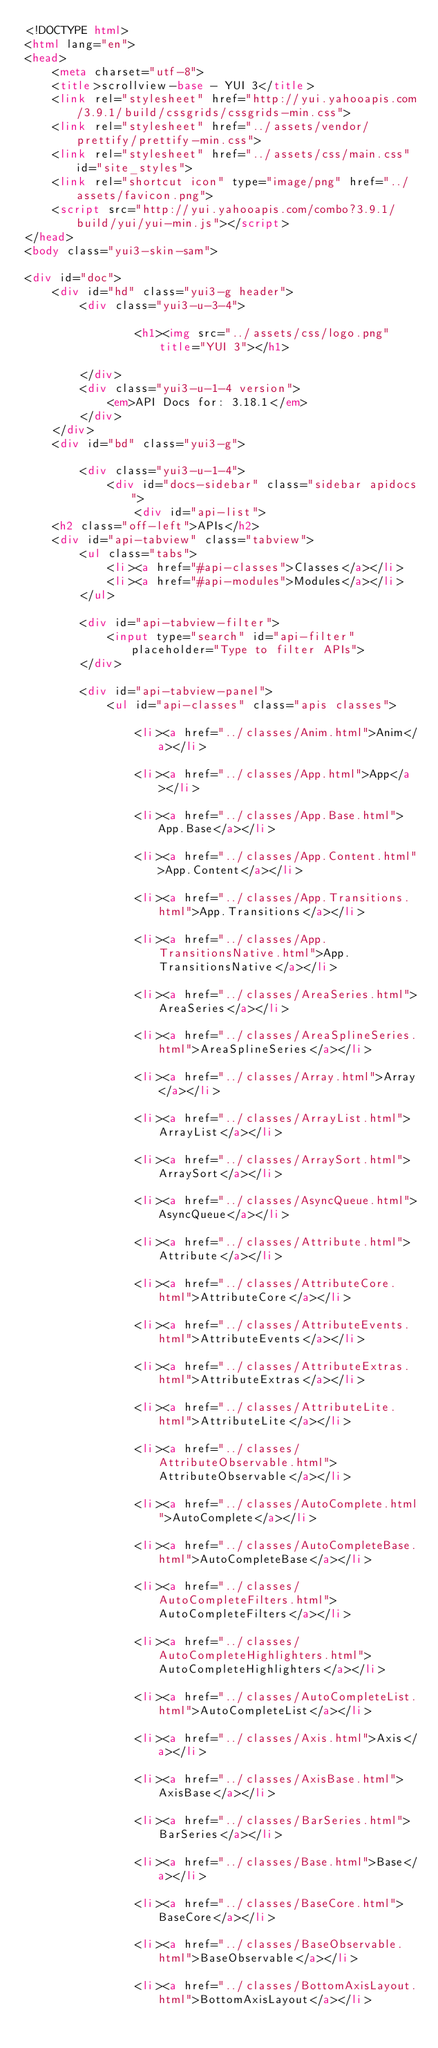Convert code to text. <code><loc_0><loc_0><loc_500><loc_500><_HTML_><!DOCTYPE html>
<html lang="en">
<head>
    <meta charset="utf-8">
    <title>scrollview-base - YUI 3</title>
    <link rel="stylesheet" href="http://yui.yahooapis.com/3.9.1/build/cssgrids/cssgrids-min.css">
    <link rel="stylesheet" href="../assets/vendor/prettify/prettify-min.css">
    <link rel="stylesheet" href="../assets/css/main.css" id="site_styles">
    <link rel="shortcut icon" type="image/png" href="../assets/favicon.png">
    <script src="http://yui.yahooapis.com/combo?3.9.1/build/yui/yui-min.js"></script>
</head>
<body class="yui3-skin-sam">

<div id="doc">
    <div id="hd" class="yui3-g header">
        <div class="yui3-u-3-4">

                <h1><img src="../assets/css/logo.png" title="YUI 3"></h1>

        </div>
        <div class="yui3-u-1-4 version">
            <em>API Docs for: 3.18.1</em>
        </div>
    </div>
    <div id="bd" class="yui3-g">

        <div class="yui3-u-1-4">
            <div id="docs-sidebar" class="sidebar apidocs">
                <div id="api-list">
    <h2 class="off-left">APIs</h2>
    <div id="api-tabview" class="tabview">
        <ul class="tabs">
            <li><a href="#api-classes">Classes</a></li>
            <li><a href="#api-modules">Modules</a></li>
        </ul>

        <div id="api-tabview-filter">
            <input type="search" id="api-filter" placeholder="Type to filter APIs">
        </div>

        <div id="api-tabview-panel">
            <ul id="api-classes" class="apis classes">

                <li><a href="../classes/Anim.html">Anim</a></li>

                <li><a href="../classes/App.html">App</a></li>

                <li><a href="../classes/App.Base.html">App.Base</a></li>

                <li><a href="../classes/App.Content.html">App.Content</a></li>

                <li><a href="../classes/App.Transitions.html">App.Transitions</a></li>

                <li><a href="../classes/App.TransitionsNative.html">App.TransitionsNative</a></li>

                <li><a href="../classes/AreaSeries.html">AreaSeries</a></li>

                <li><a href="../classes/AreaSplineSeries.html">AreaSplineSeries</a></li>

                <li><a href="../classes/Array.html">Array</a></li>

                <li><a href="../classes/ArrayList.html">ArrayList</a></li>

                <li><a href="../classes/ArraySort.html">ArraySort</a></li>

                <li><a href="../classes/AsyncQueue.html">AsyncQueue</a></li>

                <li><a href="../classes/Attribute.html">Attribute</a></li>

                <li><a href="../classes/AttributeCore.html">AttributeCore</a></li>

                <li><a href="../classes/AttributeEvents.html">AttributeEvents</a></li>

                <li><a href="../classes/AttributeExtras.html">AttributeExtras</a></li>

                <li><a href="../classes/AttributeLite.html">AttributeLite</a></li>

                <li><a href="../classes/AttributeObservable.html">AttributeObservable</a></li>

                <li><a href="../classes/AutoComplete.html">AutoComplete</a></li>

                <li><a href="../classes/AutoCompleteBase.html">AutoCompleteBase</a></li>

                <li><a href="../classes/AutoCompleteFilters.html">AutoCompleteFilters</a></li>

                <li><a href="../classes/AutoCompleteHighlighters.html">AutoCompleteHighlighters</a></li>

                <li><a href="../classes/AutoCompleteList.html">AutoCompleteList</a></li>

                <li><a href="../classes/Axis.html">Axis</a></li>

                <li><a href="../classes/AxisBase.html">AxisBase</a></li>

                <li><a href="../classes/BarSeries.html">BarSeries</a></li>

                <li><a href="../classes/Base.html">Base</a></li>

                <li><a href="../classes/BaseCore.html">BaseCore</a></li>

                <li><a href="../classes/BaseObservable.html">BaseObservable</a></li>

                <li><a href="../classes/BottomAxisLayout.html">BottomAxisLayout</a></li>
</code> 